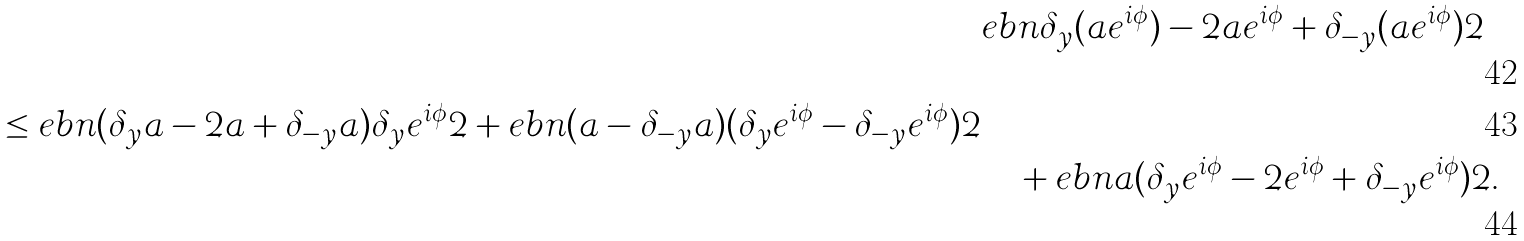Convert formula to latex. <formula><loc_0><loc_0><loc_500><loc_500>& \L e b n { \delta _ { y } ( a e ^ { i \phi } ) - 2 a e ^ { i \phi } + \delta _ { - y } ( a e ^ { i \phi } ) } 2 \\ \leq \L e b n { ( \delta _ { y } a - 2 a + \delta _ { - y } a ) \delta _ { y } e ^ { i \phi } } 2 + \L e b n { ( a - \delta _ { - y } a ) ( \delta _ { y } e ^ { i \phi } - \delta _ { - y } e ^ { i \phi } ) } 2 \\ & \quad + \L e b n { a ( \delta _ { y } e ^ { i \phi } - 2 e ^ { i \phi } + \delta _ { - y } e ^ { i \phi } ) } 2 .</formula> 